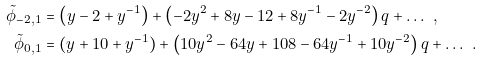Convert formula to latex. <formula><loc_0><loc_0><loc_500><loc_500>\tilde { \phi } _ { - 2 , 1 } & = \left ( y - 2 + y ^ { - 1 } \right ) + \left ( - 2 y ^ { 2 } + 8 y - 1 2 + 8 y ^ { - 1 } - 2 y ^ { - 2 } \right ) q + \dots \ , \\ \tilde { \phi } _ { 0 , 1 } & = ( y + 1 0 + y ^ { - 1 } ) + \left ( 1 0 y ^ { 2 } - 6 4 y + 1 0 8 - 6 4 y ^ { - 1 } + 1 0 y ^ { - 2 } \right ) q + \dots \ .</formula> 